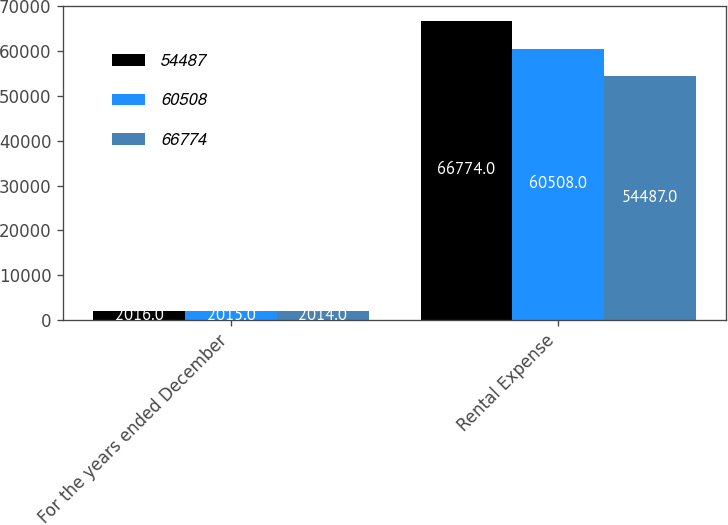<chart> <loc_0><loc_0><loc_500><loc_500><stacked_bar_chart><ecel><fcel>For the years ended December<fcel>Rental Expense<nl><fcel>54487<fcel>2016<fcel>66774<nl><fcel>60508<fcel>2015<fcel>60508<nl><fcel>66774<fcel>2014<fcel>54487<nl></chart> 